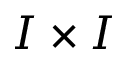<formula> <loc_0><loc_0><loc_500><loc_500>I \times I</formula> 